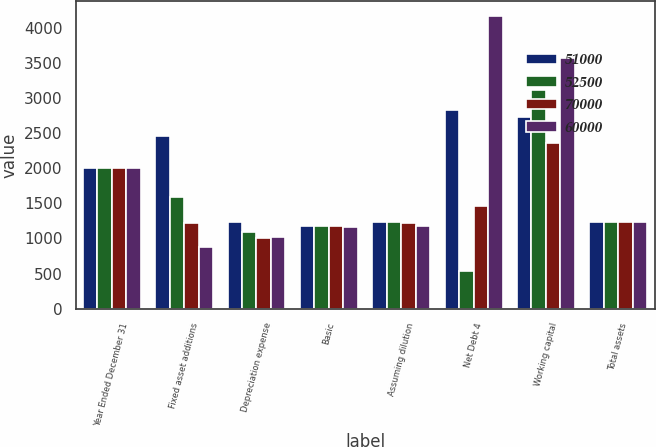Convert chart to OTSL. <chart><loc_0><loc_0><loc_500><loc_500><stacked_bar_chart><ecel><fcel>Year Ended December 31<fcel>Fixed asset additions<fcel>Depreciation expense<fcel>Basic<fcel>Assuming dilution<fcel>Net Debt 4<fcel>Working capital<fcel>Total assets<nl><fcel>51000<fcel>2006<fcel>2457<fcel>1232<fcel>1182<fcel>1242<fcel>2834<fcel>2731<fcel>1237<nl><fcel>52500<fcel>2005<fcel>1593<fcel>1092<fcel>1179<fcel>1230<fcel>532<fcel>3121<fcel>1237<nl><fcel>70000<fcel>2004<fcel>1216<fcel>1007<fcel>1178<fcel>1226<fcel>1459<fcel>2359<fcel>1237<nl><fcel>60000<fcel>2003<fcel>872<fcel>1016<fcel>1168<fcel>1173<fcel>4176<fcel>3574<fcel>1237<nl></chart> 